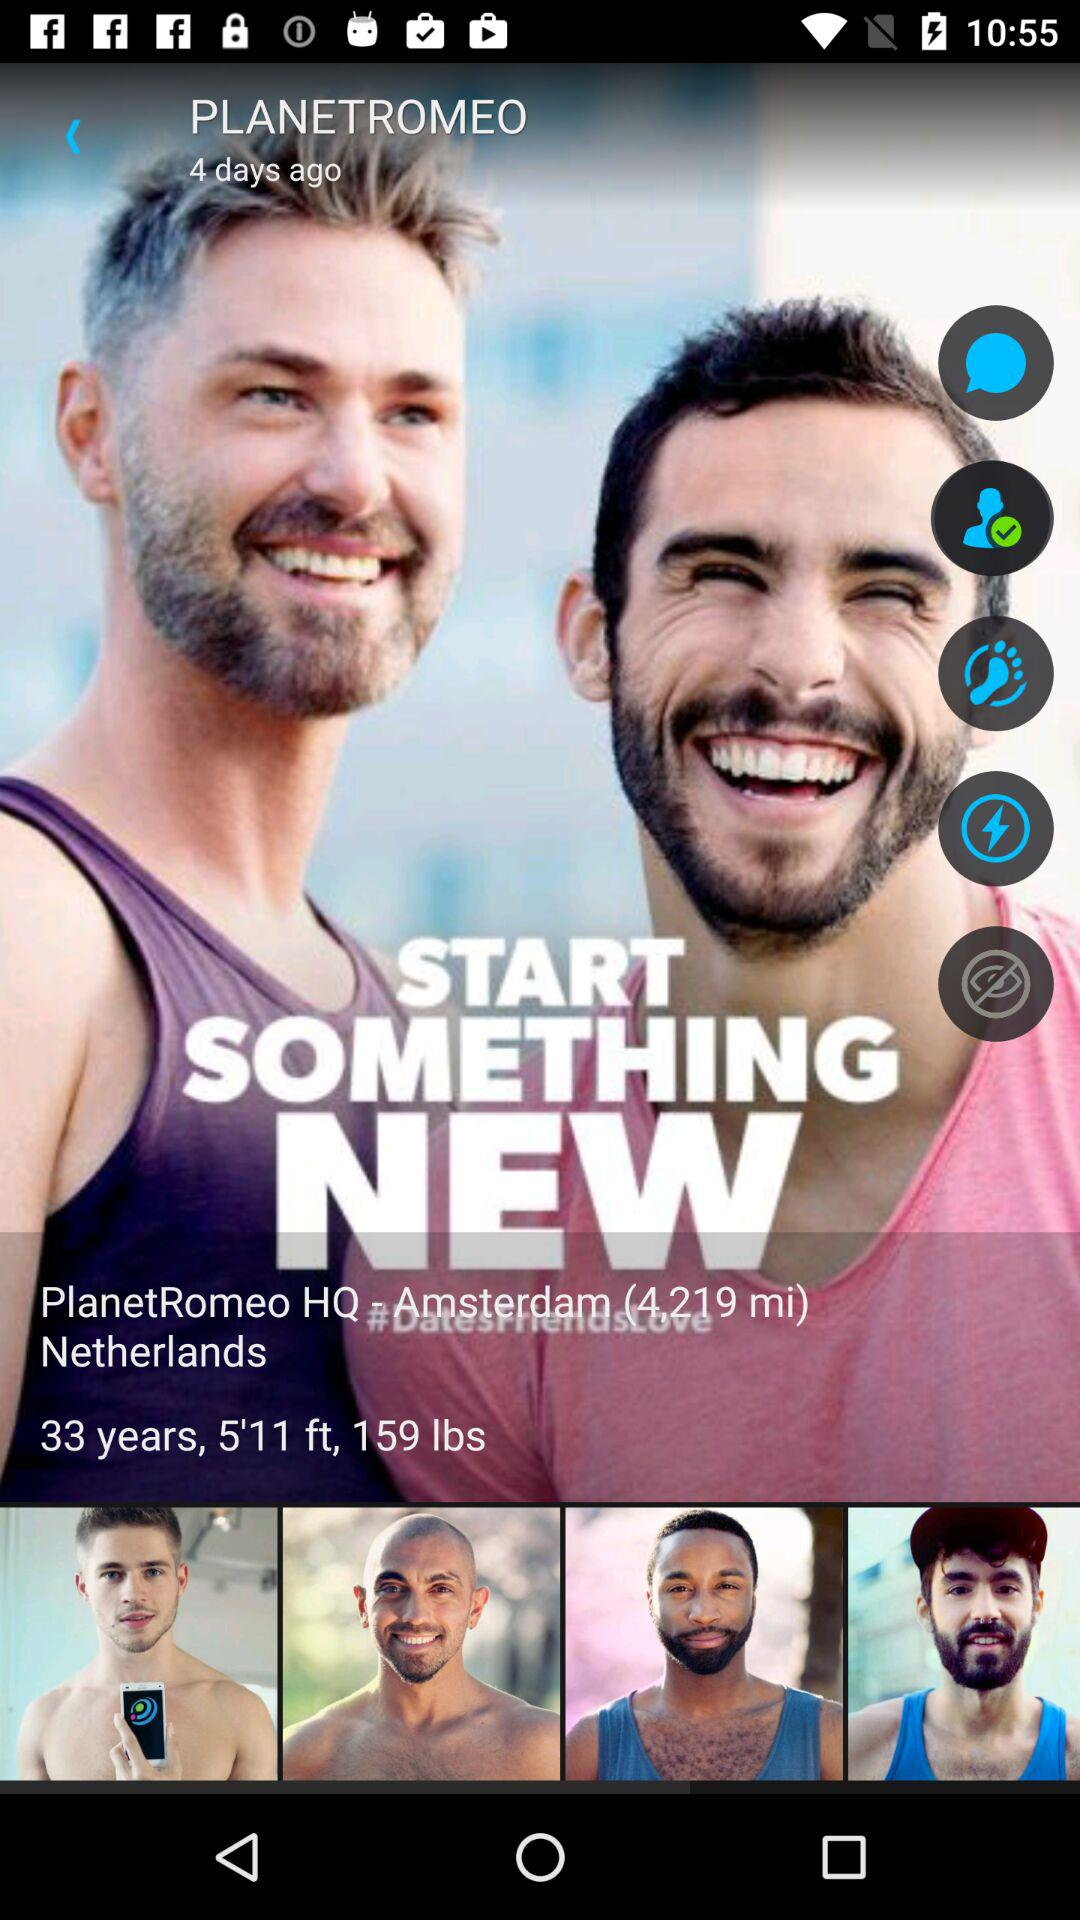In what country is PlanetRomeo HQ located? PlanetRomeo HQ is located in Netherlands. 